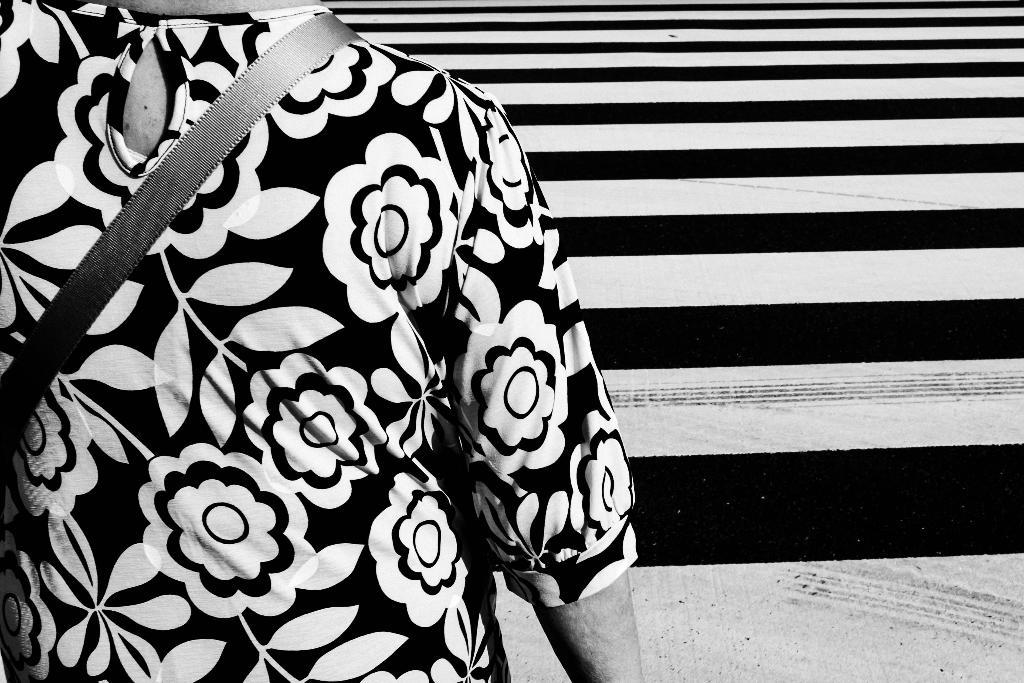What is the color scheme of the image? The image is black and white. Can you describe the person in the image? There is a person in the image. Where is the person located in relation to the stairs? The person is standing near the stairs. What type of camera can be seen in the person's hand in the image? There is no camera visible in the person's hand in the image, as it is a black and white image and the focus is on the person standing near the stairs. 